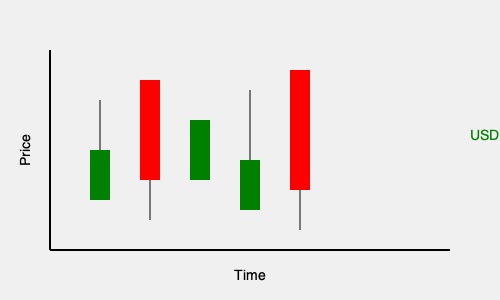Analyze the candlestick chart for the USD/BRL (US Dollar to Brazilian Real) currency pair. What pattern is forming, and what does it suggest about potential future price movements? To interpret this candlestick chart for the USD/BRL pair, we need to follow these steps:

1. Identify the candlestick colors:
   - Green candlesticks represent bullish (upward) price movements
   - Red candlesticks represent bearish (downward) price movements

2. Analyze the sequence of candlesticks:
   - We see a pattern of alternating bullish and bearish candles
   - The last two candles are a small bullish followed by a large bearish candle

3. Recognize the pattern:
   - This sequence forms a "Bearish Engulfing" pattern
   - The pattern consists of a small bullish candle followed by a larger bearish candle that completely "engulfs" the previous candle's body

4. Interpret the pattern:
   - A Bearish Engulfing pattern typically occurs at the end of an uptrend
   - It suggests a potential reversal from bullish to bearish sentiment

5. Consider the context:
   - This is an emerging market currency pair, which can be more volatile
   - The USD/BRL pair is influenced by both US and Brazilian economic factors

6. Assess potential future movements:
   - The Bearish Engulfing pattern indicates a possible downward trend
   - This could mean a strengthening of the USD against the BRL
   - However, confirmation from additional indicators or fundamental analysis is recommended

7. Risk management:
   - Traders should be cautious of potential increased volatility in emerging market currencies
   - Setting appropriate stop-loss orders is crucial to manage risk

In conclusion, the chart shows a Bearish Engulfing pattern, suggesting a potential downward trend for the USD/BRL pair in the near future, but traders should use additional analysis to confirm this signal before making trading decisions.
Answer: Bearish Engulfing pattern, suggesting potential downward trend for USD/BRL. 